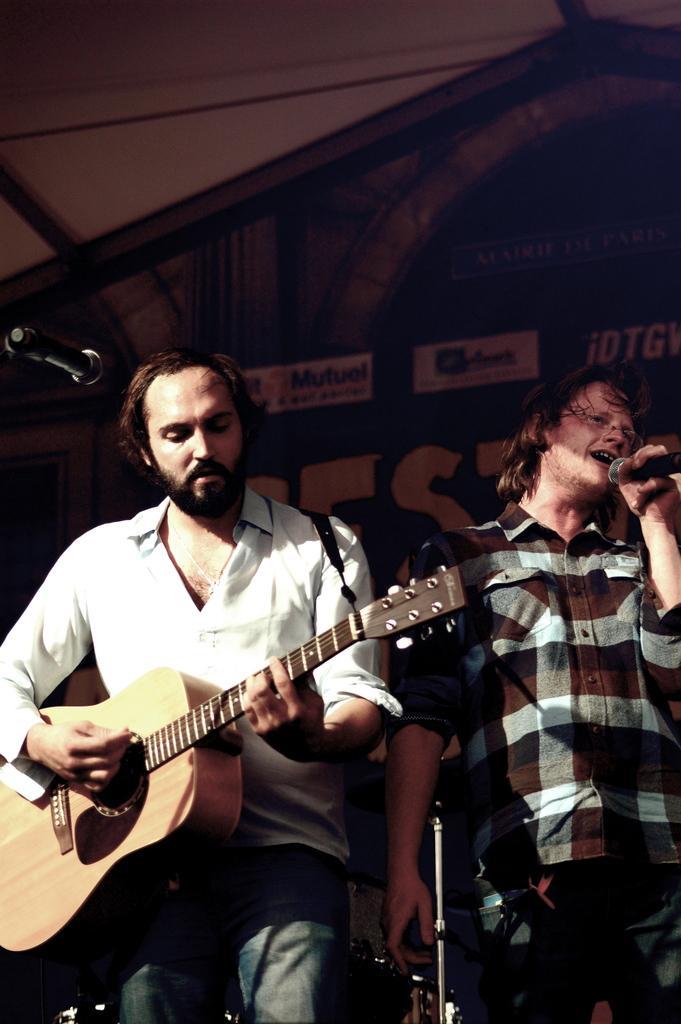How would you summarize this image in a sentence or two? In this image on the left there is a man he wears shirt and trouser he is playing guitar. On the right there is a man he wears check shirt and trouser he is singing. In the background there is a poster. 